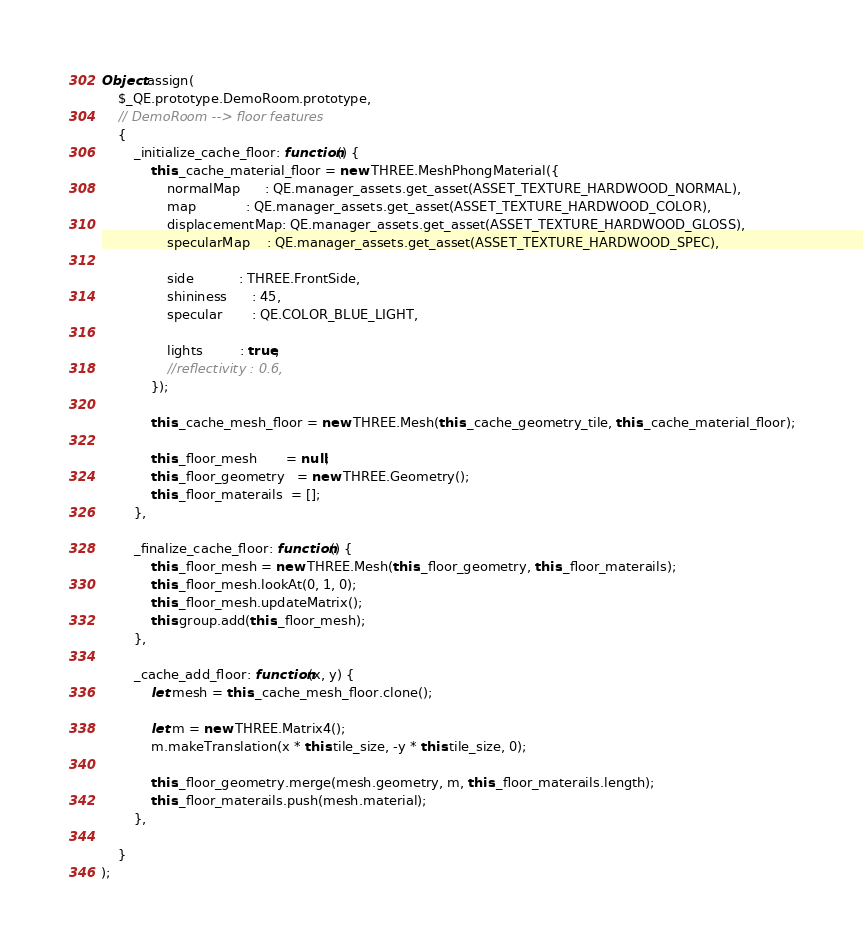<code> <loc_0><loc_0><loc_500><loc_500><_JavaScript_>Object.assign(
    $_QE.prototype.DemoRoom.prototype,
    // DemoRoom --> floor features
    {
        _initialize_cache_floor: function() {
            this._cache_material_floor = new THREE.MeshPhongMaterial({
                normalMap      : QE.manager_assets.get_asset(ASSET_TEXTURE_HARDWOOD_NORMAL),
                map            : QE.manager_assets.get_asset(ASSET_TEXTURE_HARDWOOD_COLOR),
                displacementMap: QE.manager_assets.get_asset(ASSET_TEXTURE_HARDWOOD_GLOSS),
                specularMap    : QE.manager_assets.get_asset(ASSET_TEXTURE_HARDWOOD_SPEC),

                side           : THREE.FrontSide,
                shininess      : 45,
                specular       : QE.COLOR_BLUE_LIGHT,

                lights         : true,
                //reflectivity : 0.6,
            });

            this._cache_mesh_floor = new THREE.Mesh(this._cache_geometry_tile, this._cache_material_floor);

            this._floor_mesh       = null;
            this._floor_geometry   = new THREE.Geometry();
            this._floor_materails  = [];
        },

        _finalize_cache_floor: function() {
            this._floor_mesh = new THREE.Mesh(this._floor_geometry, this._floor_materails);
            this._floor_mesh.lookAt(0, 1, 0);
            this._floor_mesh.updateMatrix();
            this.group.add(this._floor_mesh);
        },

        _cache_add_floor: function(x, y) {
            let mesh = this._cache_mesh_floor.clone();

            let m = new THREE.Matrix4();
            m.makeTranslation(x * this.tile_size, -y * this.tile_size, 0);

            this._floor_geometry.merge(mesh.geometry, m, this._floor_materails.length);
            this._floor_materails.push(mesh.material);
        },

    }
);
</code> 